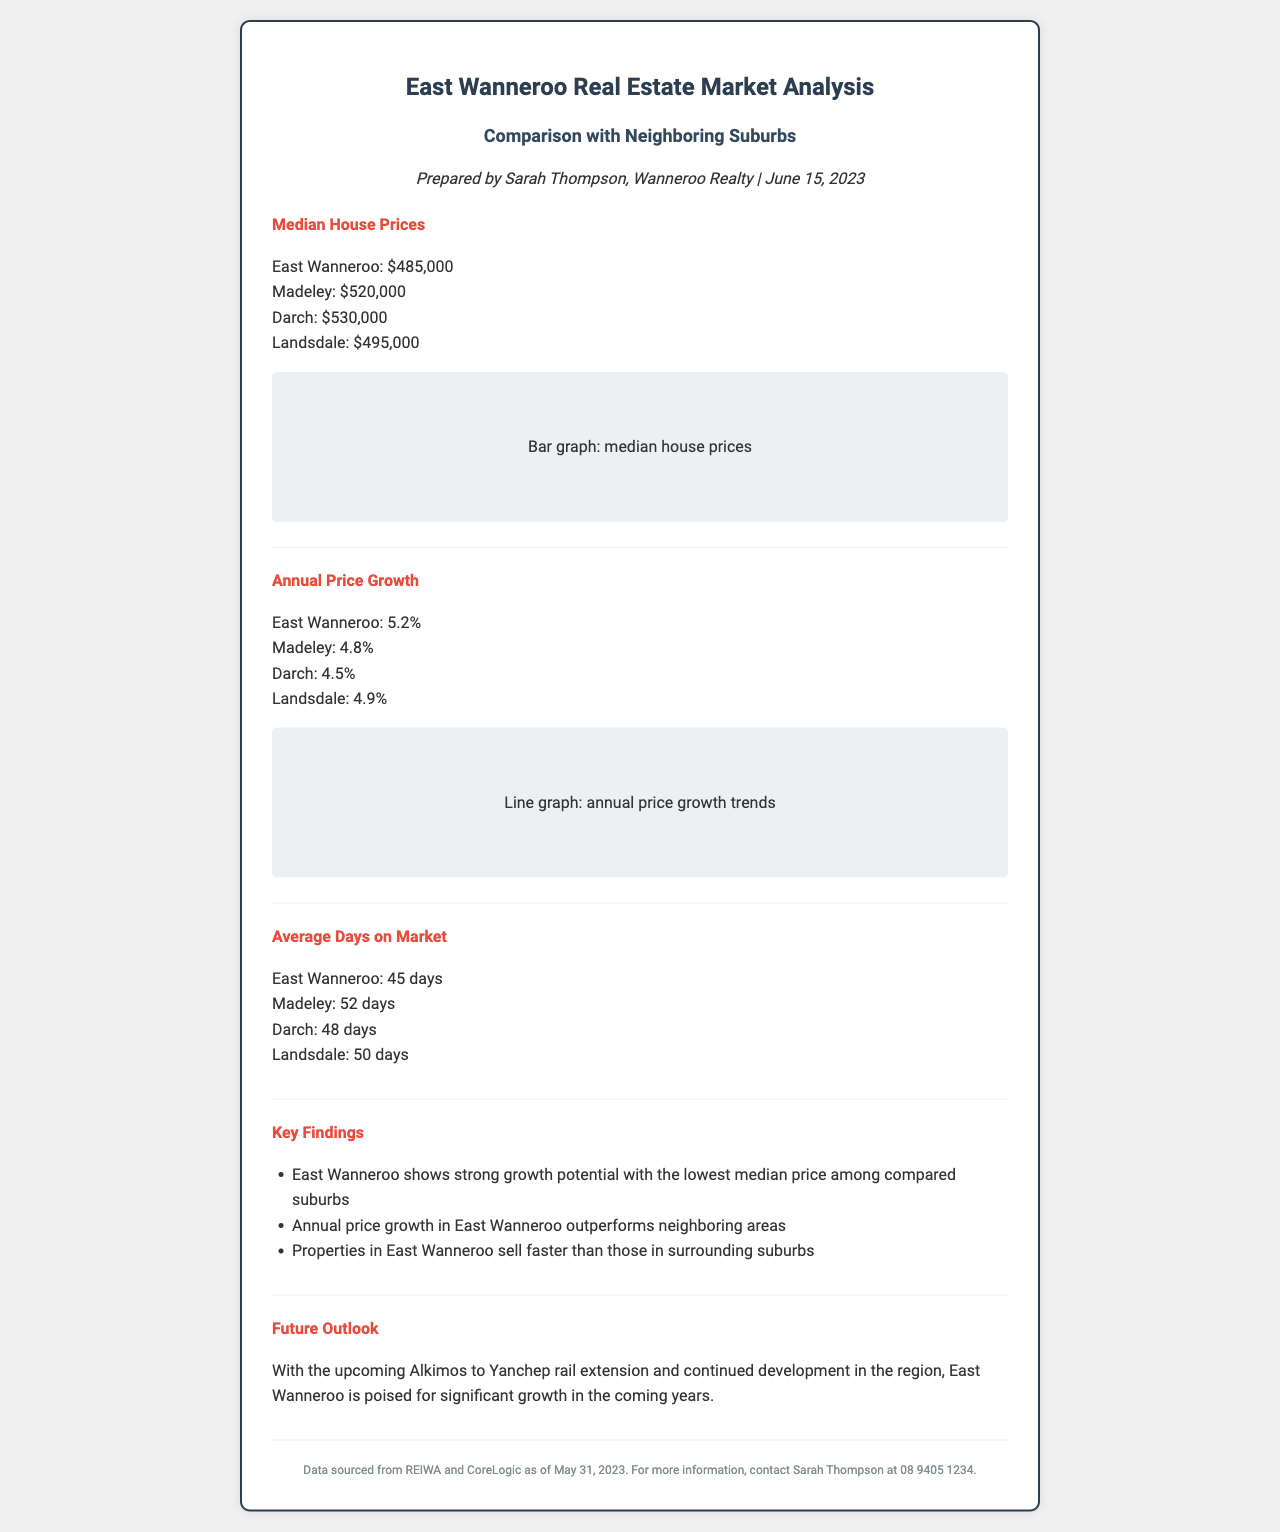What is the median house price in East Wanneroo? The median house price provided in the document for East Wanneroo is $485,000.
Answer: $485,000 What is the annual price growth for East Wanneroo? The document states that the annual price growth in East Wanneroo is 5.2%.
Answer: 5.2% How many days do properties in East Wanneroo typically stay on the market? The document mentions that properties in East Wanneroo are on the market for 45 days on average.
Answer: 45 days Which suburb has the highest median house price? The document provides that Darch has the highest median house price at $530,000.
Answer: Darch What key advantage does East Wanneroo have compared to neighboring suburbs? One key advantage stated in the document is that East Wanneroo shows strong growth potential with the lowest median price among compared suburbs.
Answer: Strong growth potential with the lowest median price Why is East Wanneroo poised for significant growth in the coming years? The document indicates that the upcoming Alkimos to Yanchep rail extension and continued development in the region are reasons for significant growth.
Answer: Rail extension and development Who prepared the market analysis report? The document credits the market analysis report to Sarah Thompson of Wanneroo Realty.
Answer: Sarah Thompson When was the market analysis report prepared? The document specifies that the market analysis report was prepared on June 15, 2023.
Answer: June 15, 2023 